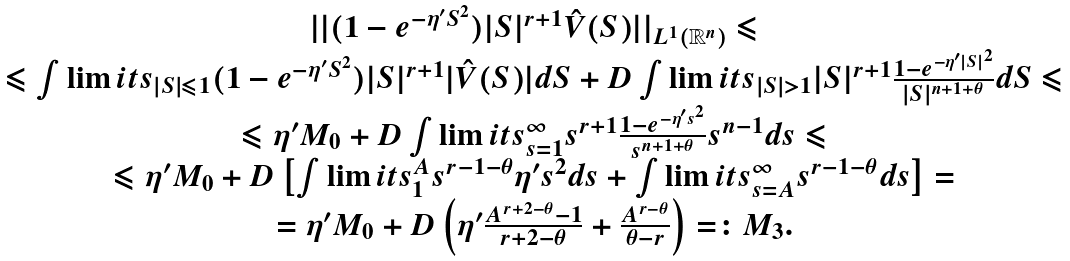Convert formula to latex. <formula><loc_0><loc_0><loc_500><loc_500>\begin{array} { c } | | ( 1 - e ^ { - \eta ^ { \prime } S ^ { 2 } } ) | S | ^ { r + 1 } \hat { V } ( S ) | | _ { L ^ { 1 } ( \mathbb { R } ^ { n } ) } \leqslant \\ \leqslant \int \lim i t s _ { | S | \leqslant 1 } { ( 1 - e ^ { - \eta ^ { \prime } S ^ { 2 } } ) | S | ^ { r + 1 } | \hat { V } ( S ) | d S } + D \int \lim i t s _ { | S | > 1 } { | S | ^ { r + 1 } \frac { 1 - e ^ { - \eta ^ { \prime } | S | ^ { 2 } } } { | S | ^ { n + 1 + \theta } } d S } \leqslant \\ \leqslant \eta ^ { \prime } M _ { 0 } + D \int \lim i t s _ { s = 1 } ^ { \infty } { s ^ { r + 1 } \frac { 1 - e ^ { - \eta ^ { \prime } s ^ { 2 } } } { s ^ { n + 1 + \theta } } s ^ { n - 1 } d s } \leqslant \\ \leqslant \eta ^ { \prime } M _ { 0 } + D \left [ { \int \lim i t s _ { 1 } ^ { A } { s ^ { r - 1 - \theta } \eta ^ { \prime } s ^ { 2 } d s } + \int \lim i t s _ { s = A } ^ { \infty } { s ^ { r - 1 - \theta } d s } } \right ] = \\ = \eta ^ { \prime } M _ { 0 } + D \left ( { \eta ^ { \prime } \frac { A ^ { r + 2 - \theta } - 1 } { r + 2 - \theta } + \frac { A ^ { r - \theta } } { \theta - r } } \right ) = \colon M _ { 3 } . \end{array}</formula> 